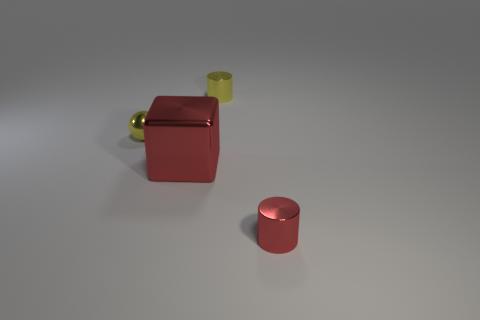Is there anything else that is the same size as the cube?
Provide a succinct answer. No. There is a yellow object that is the same size as the yellow metal ball; what is its shape?
Your answer should be very brief. Cylinder. How many rubber things are tiny red cylinders or small gray objects?
Provide a succinct answer. 0. Does the tiny yellow thing behind the metallic ball have the same material as the small object in front of the yellow shiny ball?
Make the answer very short. Yes. The sphere that is the same material as the tiny red thing is what color?
Your answer should be very brief. Yellow. Are there more big red shiny blocks that are on the left side of the yellow metal ball than small yellow cylinders that are on the right side of the large block?
Provide a succinct answer. No. Are there any tiny red matte cylinders?
Keep it short and to the point. No. There is a thing that is the same color as the cube; what is its material?
Provide a succinct answer. Metal. How many objects are tiny yellow cylinders or cylinders?
Make the answer very short. 2. Is there a big metallic cube of the same color as the tiny shiny sphere?
Provide a short and direct response. No. 